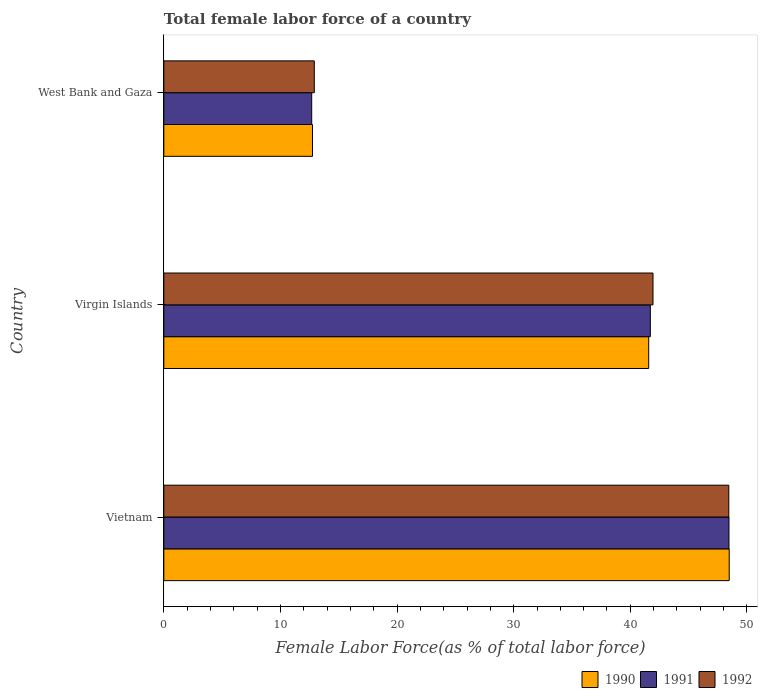How many groups of bars are there?
Provide a succinct answer. 3. Are the number of bars per tick equal to the number of legend labels?
Your response must be concise. Yes. How many bars are there on the 2nd tick from the top?
Your answer should be very brief. 3. What is the label of the 3rd group of bars from the top?
Provide a short and direct response. Vietnam. In how many cases, is the number of bars for a given country not equal to the number of legend labels?
Ensure brevity in your answer.  0. What is the percentage of female labor force in 1992 in Virgin Islands?
Your answer should be very brief. 41.95. Across all countries, what is the maximum percentage of female labor force in 1992?
Give a very brief answer. 48.45. Across all countries, what is the minimum percentage of female labor force in 1992?
Give a very brief answer. 12.9. In which country was the percentage of female labor force in 1992 maximum?
Your response must be concise. Vietnam. In which country was the percentage of female labor force in 1992 minimum?
Offer a very short reply. West Bank and Gaza. What is the total percentage of female labor force in 1992 in the graph?
Provide a succinct answer. 103.3. What is the difference between the percentage of female labor force in 1990 in Vietnam and that in West Bank and Gaza?
Your response must be concise. 35.74. What is the difference between the percentage of female labor force in 1990 in Virgin Islands and the percentage of female labor force in 1992 in Vietnam?
Give a very brief answer. -6.87. What is the average percentage of female labor force in 1990 per country?
Keep it short and to the point. 34.27. What is the difference between the percentage of female labor force in 1992 and percentage of female labor force in 1991 in West Bank and Gaza?
Provide a short and direct response. 0.22. What is the ratio of the percentage of female labor force in 1992 in Vietnam to that in West Bank and Gaza?
Your answer should be compact. 3.75. Is the difference between the percentage of female labor force in 1992 in Vietnam and Virgin Islands greater than the difference between the percentage of female labor force in 1991 in Vietnam and Virgin Islands?
Provide a succinct answer. No. What is the difference between the highest and the second highest percentage of female labor force in 1990?
Keep it short and to the point. 6.91. What is the difference between the highest and the lowest percentage of female labor force in 1992?
Ensure brevity in your answer.  35.54. In how many countries, is the percentage of female labor force in 1992 greater than the average percentage of female labor force in 1992 taken over all countries?
Ensure brevity in your answer.  2. What does the 1st bar from the bottom in West Bank and Gaza represents?
Provide a succinct answer. 1990. Is it the case that in every country, the sum of the percentage of female labor force in 1990 and percentage of female labor force in 1991 is greater than the percentage of female labor force in 1992?
Make the answer very short. Yes. Are all the bars in the graph horizontal?
Keep it short and to the point. Yes. What is the difference between two consecutive major ticks on the X-axis?
Your response must be concise. 10. Are the values on the major ticks of X-axis written in scientific E-notation?
Provide a short and direct response. No. Does the graph contain any zero values?
Your answer should be compact. No. Where does the legend appear in the graph?
Keep it short and to the point. Bottom right. What is the title of the graph?
Provide a short and direct response. Total female labor force of a country. Does "1987" appear as one of the legend labels in the graph?
Offer a very short reply. No. What is the label or title of the X-axis?
Provide a succinct answer. Female Labor Force(as % of total labor force). What is the label or title of the Y-axis?
Your answer should be compact. Country. What is the Female Labor Force(as % of total labor force) in 1990 in Vietnam?
Keep it short and to the point. 48.48. What is the Female Labor Force(as % of total labor force) in 1991 in Vietnam?
Offer a very short reply. 48.46. What is the Female Labor Force(as % of total labor force) in 1992 in Vietnam?
Provide a short and direct response. 48.45. What is the Female Labor Force(as % of total labor force) in 1990 in Virgin Islands?
Give a very brief answer. 41.58. What is the Female Labor Force(as % of total labor force) in 1991 in Virgin Islands?
Your answer should be compact. 41.72. What is the Female Labor Force(as % of total labor force) in 1992 in Virgin Islands?
Keep it short and to the point. 41.95. What is the Female Labor Force(as % of total labor force) of 1990 in West Bank and Gaza?
Offer a terse response. 12.75. What is the Female Labor Force(as % of total labor force) in 1991 in West Bank and Gaza?
Offer a terse response. 12.68. What is the Female Labor Force(as % of total labor force) in 1992 in West Bank and Gaza?
Your response must be concise. 12.9. Across all countries, what is the maximum Female Labor Force(as % of total labor force) in 1990?
Offer a terse response. 48.48. Across all countries, what is the maximum Female Labor Force(as % of total labor force) in 1991?
Give a very brief answer. 48.46. Across all countries, what is the maximum Female Labor Force(as % of total labor force) in 1992?
Your answer should be very brief. 48.45. Across all countries, what is the minimum Female Labor Force(as % of total labor force) of 1990?
Your response must be concise. 12.75. Across all countries, what is the minimum Female Labor Force(as % of total labor force) in 1991?
Your response must be concise. 12.68. Across all countries, what is the minimum Female Labor Force(as % of total labor force) of 1992?
Give a very brief answer. 12.9. What is the total Female Labor Force(as % of total labor force) in 1990 in the graph?
Ensure brevity in your answer.  102.81. What is the total Female Labor Force(as % of total labor force) in 1991 in the graph?
Your answer should be very brief. 102.86. What is the total Female Labor Force(as % of total labor force) of 1992 in the graph?
Your response must be concise. 103.3. What is the difference between the Female Labor Force(as % of total labor force) in 1990 in Vietnam and that in Virgin Islands?
Your answer should be very brief. 6.91. What is the difference between the Female Labor Force(as % of total labor force) in 1991 in Vietnam and that in Virgin Islands?
Make the answer very short. 6.74. What is the difference between the Female Labor Force(as % of total labor force) of 1992 in Vietnam and that in Virgin Islands?
Your answer should be compact. 6.5. What is the difference between the Female Labor Force(as % of total labor force) in 1990 in Vietnam and that in West Bank and Gaza?
Your answer should be very brief. 35.74. What is the difference between the Female Labor Force(as % of total labor force) in 1991 in Vietnam and that in West Bank and Gaza?
Your answer should be very brief. 35.78. What is the difference between the Female Labor Force(as % of total labor force) of 1992 in Vietnam and that in West Bank and Gaza?
Your response must be concise. 35.54. What is the difference between the Female Labor Force(as % of total labor force) in 1990 in Virgin Islands and that in West Bank and Gaza?
Your response must be concise. 28.83. What is the difference between the Female Labor Force(as % of total labor force) of 1991 in Virgin Islands and that in West Bank and Gaza?
Your response must be concise. 29.04. What is the difference between the Female Labor Force(as % of total labor force) of 1992 in Virgin Islands and that in West Bank and Gaza?
Provide a succinct answer. 29.04. What is the difference between the Female Labor Force(as % of total labor force) in 1990 in Vietnam and the Female Labor Force(as % of total labor force) in 1991 in Virgin Islands?
Your answer should be very brief. 6.76. What is the difference between the Female Labor Force(as % of total labor force) of 1990 in Vietnam and the Female Labor Force(as % of total labor force) of 1992 in Virgin Islands?
Your response must be concise. 6.54. What is the difference between the Female Labor Force(as % of total labor force) of 1991 in Vietnam and the Female Labor Force(as % of total labor force) of 1992 in Virgin Islands?
Give a very brief answer. 6.52. What is the difference between the Female Labor Force(as % of total labor force) of 1990 in Vietnam and the Female Labor Force(as % of total labor force) of 1991 in West Bank and Gaza?
Give a very brief answer. 35.8. What is the difference between the Female Labor Force(as % of total labor force) in 1990 in Vietnam and the Female Labor Force(as % of total labor force) in 1992 in West Bank and Gaza?
Provide a succinct answer. 35.58. What is the difference between the Female Labor Force(as % of total labor force) in 1991 in Vietnam and the Female Labor Force(as % of total labor force) in 1992 in West Bank and Gaza?
Your response must be concise. 35.56. What is the difference between the Female Labor Force(as % of total labor force) of 1990 in Virgin Islands and the Female Labor Force(as % of total labor force) of 1991 in West Bank and Gaza?
Ensure brevity in your answer.  28.9. What is the difference between the Female Labor Force(as % of total labor force) of 1990 in Virgin Islands and the Female Labor Force(as % of total labor force) of 1992 in West Bank and Gaza?
Offer a very short reply. 28.67. What is the difference between the Female Labor Force(as % of total labor force) in 1991 in Virgin Islands and the Female Labor Force(as % of total labor force) in 1992 in West Bank and Gaza?
Your answer should be very brief. 28.82. What is the average Female Labor Force(as % of total labor force) in 1990 per country?
Ensure brevity in your answer.  34.27. What is the average Female Labor Force(as % of total labor force) of 1991 per country?
Your answer should be compact. 34.29. What is the average Female Labor Force(as % of total labor force) in 1992 per country?
Your answer should be very brief. 34.43. What is the difference between the Female Labor Force(as % of total labor force) in 1990 and Female Labor Force(as % of total labor force) in 1991 in Vietnam?
Provide a short and direct response. 0.02. What is the difference between the Female Labor Force(as % of total labor force) in 1990 and Female Labor Force(as % of total labor force) in 1992 in Vietnam?
Give a very brief answer. 0.04. What is the difference between the Female Labor Force(as % of total labor force) of 1991 and Female Labor Force(as % of total labor force) of 1992 in Vietnam?
Provide a succinct answer. 0.02. What is the difference between the Female Labor Force(as % of total labor force) of 1990 and Female Labor Force(as % of total labor force) of 1991 in Virgin Islands?
Your answer should be compact. -0.14. What is the difference between the Female Labor Force(as % of total labor force) of 1990 and Female Labor Force(as % of total labor force) of 1992 in Virgin Islands?
Your response must be concise. -0.37. What is the difference between the Female Labor Force(as % of total labor force) of 1991 and Female Labor Force(as % of total labor force) of 1992 in Virgin Islands?
Make the answer very short. -0.23. What is the difference between the Female Labor Force(as % of total labor force) of 1990 and Female Labor Force(as % of total labor force) of 1991 in West Bank and Gaza?
Your answer should be very brief. 0.07. What is the difference between the Female Labor Force(as % of total labor force) of 1990 and Female Labor Force(as % of total labor force) of 1992 in West Bank and Gaza?
Ensure brevity in your answer.  -0.16. What is the difference between the Female Labor Force(as % of total labor force) in 1991 and Female Labor Force(as % of total labor force) in 1992 in West Bank and Gaza?
Your answer should be very brief. -0.22. What is the ratio of the Female Labor Force(as % of total labor force) in 1990 in Vietnam to that in Virgin Islands?
Provide a succinct answer. 1.17. What is the ratio of the Female Labor Force(as % of total labor force) in 1991 in Vietnam to that in Virgin Islands?
Provide a succinct answer. 1.16. What is the ratio of the Female Labor Force(as % of total labor force) in 1992 in Vietnam to that in Virgin Islands?
Your answer should be compact. 1.15. What is the ratio of the Female Labor Force(as % of total labor force) of 1990 in Vietnam to that in West Bank and Gaza?
Your answer should be very brief. 3.8. What is the ratio of the Female Labor Force(as % of total labor force) in 1991 in Vietnam to that in West Bank and Gaza?
Your answer should be very brief. 3.82. What is the ratio of the Female Labor Force(as % of total labor force) of 1992 in Vietnam to that in West Bank and Gaza?
Provide a succinct answer. 3.75. What is the ratio of the Female Labor Force(as % of total labor force) in 1990 in Virgin Islands to that in West Bank and Gaza?
Give a very brief answer. 3.26. What is the ratio of the Female Labor Force(as % of total labor force) of 1991 in Virgin Islands to that in West Bank and Gaza?
Your response must be concise. 3.29. What is the ratio of the Female Labor Force(as % of total labor force) of 1992 in Virgin Islands to that in West Bank and Gaza?
Ensure brevity in your answer.  3.25. What is the difference between the highest and the second highest Female Labor Force(as % of total labor force) of 1990?
Offer a very short reply. 6.91. What is the difference between the highest and the second highest Female Labor Force(as % of total labor force) in 1991?
Your answer should be compact. 6.74. What is the difference between the highest and the second highest Female Labor Force(as % of total labor force) in 1992?
Your response must be concise. 6.5. What is the difference between the highest and the lowest Female Labor Force(as % of total labor force) in 1990?
Provide a succinct answer. 35.74. What is the difference between the highest and the lowest Female Labor Force(as % of total labor force) in 1991?
Offer a terse response. 35.78. What is the difference between the highest and the lowest Female Labor Force(as % of total labor force) in 1992?
Your response must be concise. 35.54. 